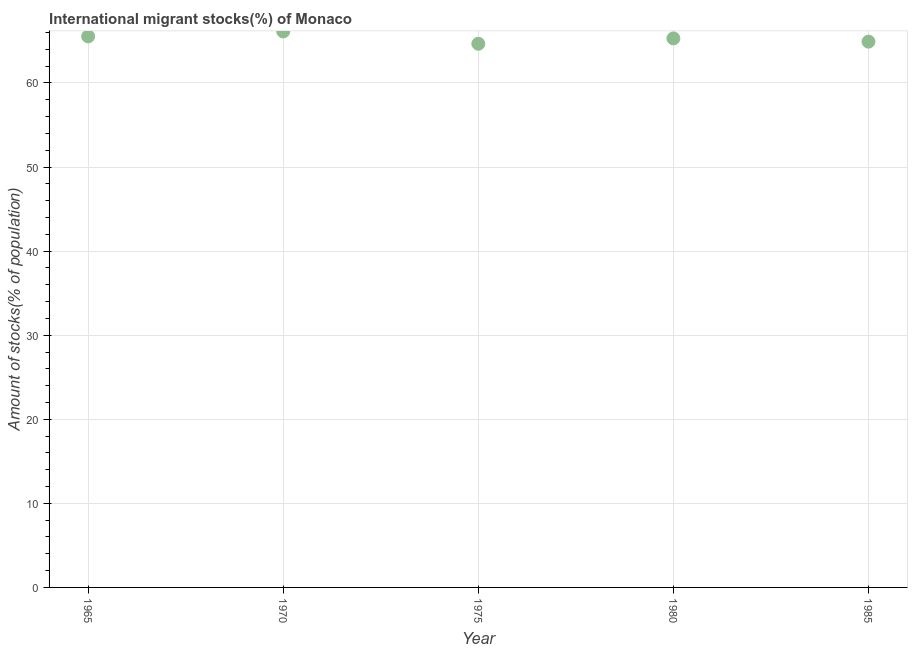What is the number of international migrant stocks in 1965?
Offer a very short reply. 65.54. Across all years, what is the maximum number of international migrant stocks?
Give a very brief answer. 66.13. Across all years, what is the minimum number of international migrant stocks?
Your answer should be very brief. 64.66. In which year was the number of international migrant stocks maximum?
Your response must be concise. 1970. In which year was the number of international migrant stocks minimum?
Offer a terse response. 1975. What is the sum of the number of international migrant stocks?
Your answer should be very brief. 326.55. What is the difference between the number of international migrant stocks in 1970 and 1985?
Your answer should be compact. 1.21. What is the average number of international migrant stocks per year?
Provide a short and direct response. 65.31. What is the median number of international migrant stocks?
Offer a very short reply. 65.3. In how many years, is the number of international migrant stocks greater than 36 %?
Your answer should be very brief. 5. Do a majority of the years between 1965 and 1980 (inclusive) have number of international migrant stocks greater than 18 %?
Offer a terse response. Yes. What is the ratio of the number of international migrant stocks in 1965 to that in 1980?
Ensure brevity in your answer.  1. Is the number of international migrant stocks in 1965 less than that in 1975?
Provide a short and direct response. No. Is the difference between the number of international migrant stocks in 1965 and 1980 greater than the difference between any two years?
Make the answer very short. No. What is the difference between the highest and the second highest number of international migrant stocks?
Keep it short and to the point. 0.59. What is the difference between the highest and the lowest number of international migrant stocks?
Provide a short and direct response. 1.47. In how many years, is the number of international migrant stocks greater than the average number of international migrant stocks taken over all years?
Your answer should be very brief. 2. Does the number of international migrant stocks monotonically increase over the years?
Provide a succinct answer. No. How many dotlines are there?
Your answer should be compact. 1. How many years are there in the graph?
Your answer should be very brief. 5. What is the difference between two consecutive major ticks on the Y-axis?
Provide a short and direct response. 10. Does the graph contain any zero values?
Your response must be concise. No. Does the graph contain grids?
Keep it short and to the point. Yes. What is the title of the graph?
Keep it short and to the point. International migrant stocks(%) of Monaco. What is the label or title of the Y-axis?
Provide a succinct answer. Amount of stocks(% of population). What is the Amount of stocks(% of population) in 1965?
Your response must be concise. 65.54. What is the Amount of stocks(% of population) in 1970?
Ensure brevity in your answer.  66.13. What is the Amount of stocks(% of population) in 1975?
Your answer should be very brief. 64.66. What is the Amount of stocks(% of population) in 1980?
Ensure brevity in your answer.  65.3. What is the Amount of stocks(% of population) in 1985?
Provide a short and direct response. 64.92. What is the difference between the Amount of stocks(% of population) in 1965 and 1970?
Provide a succinct answer. -0.59. What is the difference between the Amount of stocks(% of population) in 1965 and 1975?
Your answer should be compact. 0.88. What is the difference between the Amount of stocks(% of population) in 1965 and 1980?
Make the answer very short. 0.24. What is the difference between the Amount of stocks(% of population) in 1965 and 1985?
Keep it short and to the point. 0.63. What is the difference between the Amount of stocks(% of population) in 1970 and 1975?
Offer a very short reply. 1.47. What is the difference between the Amount of stocks(% of population) in 1970 and 1980?
Your answer should be very brief. 0.83. What is the difference between the Amount of stocks(% of population) in 1970 and 1985?
Offer a very short reply. 1.21. What is the difference between the Amount of stocks(% of population) in 1975 and 1980?
Offer a very short reply. -0.64. What is the difference between the Amount of stocks(% of population) in 1975 and 1985?
Your response must be concise. -0.25. What is the difference between the Amount of stocks(% of population) in 1980 and 1985?
Make the answer very short. 0.39. What is the ratio of the Amount of stocks(% of population) in 1965 to that in 1970?
Ensure brevity in your answer.  0.99. What is the ratio of the Amount of stocks(% of population) in 1965 to that in 1975?
Provide a succinct answer. 1.01. What is the ratio of the Amount of stocks(% of population) in 1965 to that in 1980?
Offer a terse response. 1. What is the ratio of the Amount of stocks(% of population) in 1970 to that in 1975?
Your answer should be very brief. 1.02. What is the ratio of the Amount of stocks(% of population) in 1970 to that in 1985?
Offer a terse response. 1.02. What is the ratio of the Amount of stocks(% of population) in 1975 to that in 1980?
Give a very brief answer. 0.99. What is the ratio of the Amount of stocks(% of population) in 1975 to that in 1985?
Provide a succinct answer. 1. What is the ratio of the Amount of stocks(% of population) in 1980 to that in 1985?
Your response must be concise. 1.01. 